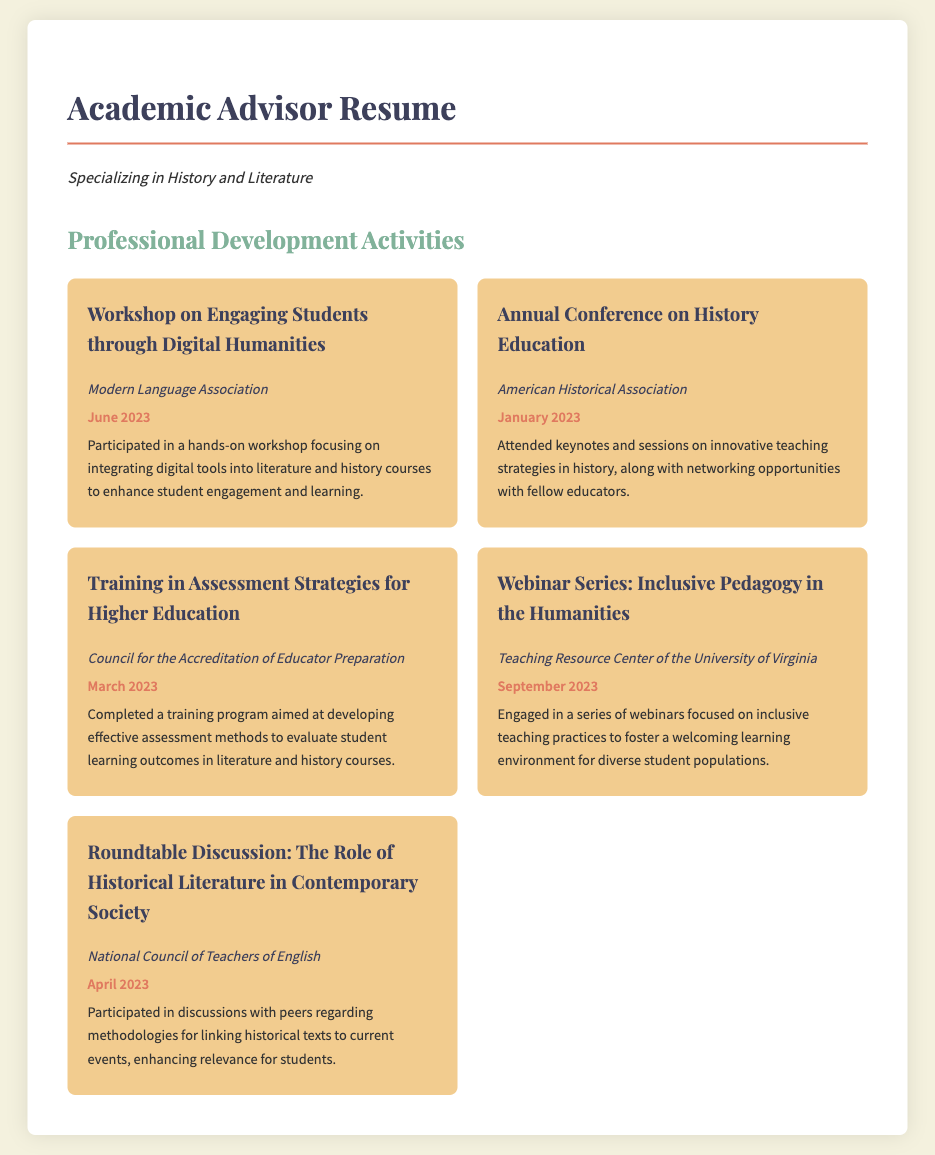What was the focus of the workshop attended in June 2023? The workshop focused on integrating digital tools into literature and history courses to enhance student engagement and learning.
Answer: Engaging Students through Digital Humanities Which organization hosted the Annual Conference on History Education? The document specifies that the Annual Conference on History Education was hosted by the American Historical Association.
Answer: American Historical Association When did the training in assessment strategies take place? The training in assessment strategies was completed in March 2023.
Answer: March 2023 What type of pedagogy was discussed in the Webinar Series? The Webinar Series focused on inclusive pedagogy in the humanities.
Answer: Inclusive Pedagogy What event occurred in April 2023? The Roundtable Discussion: The Role of Historical Literature in Contemporary Society took place in April 2023.
Answer: Roundtable Discussion: The Role of Historical Literature in Contemporary Society How many professional development activities are listed in the document? The document lists five professional development activities.
Answer: Five 